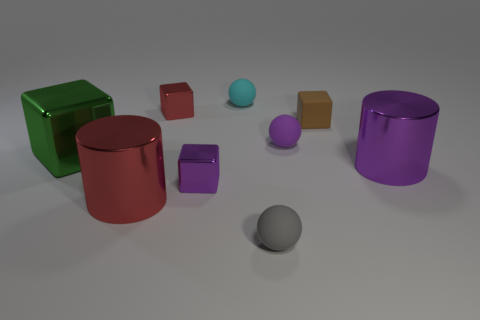Add 1 red balls. How many objects exist? 10 Subtract all small purple balls. How many balls are left? 2 Add 1 large green shiny things. How many large green shiny things exist? 2 Subtract all brown cubes. How many cubes are left? 3 Subtract 1 purple cylinders. How many objects are left? 8 Subtract all cylinders. How many objects are left? 7 Subtract 1 cylinders. How many cylinders are left? 1 Subtract all brown spheres. Subtract all cyan cubes. How many spheres are left? 3 Subtract all gray cylinders. How many purple cubes are left? 1 Subtract all large green metal cubes. Subtract all rubber spheres. How many objects are left? 5 